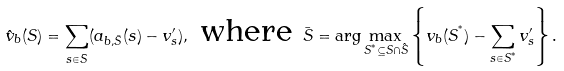<formula> <loc_0><loc_0><loc_500><loc_500>\hat { v } _ { b } ( S ) = \sum _ { s \in \bar { S } } ( a _ { b , \bar { S } } ( s ) - v ^ { \prime } _ { s } ) , \text { where } \bar { S } = \arg \max _ { S ^ { ^ { * } } \subseteq S \cap \hat { S } } \left \{ v _ { b } ( S ^ { ^ { * } } ) - \sum _ { s \in S ^ { ^ { * } } } v ^ { \prime } _ { s } \right \} .</formula> 